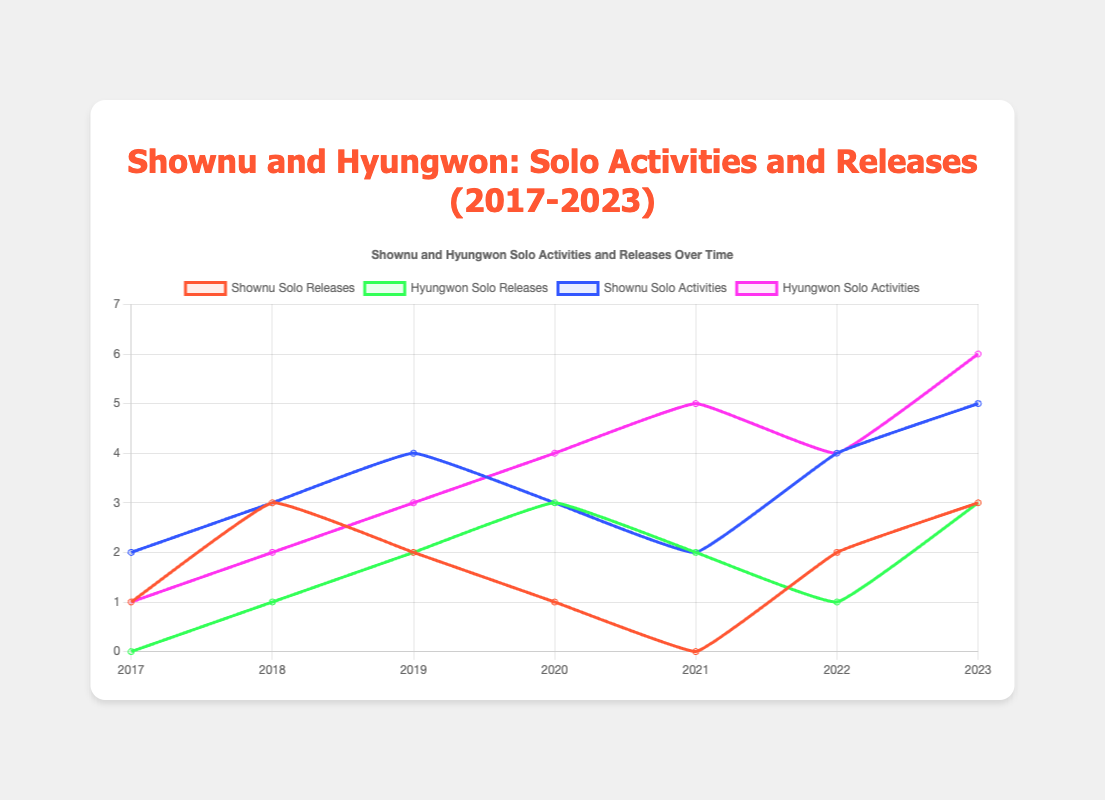How many more solo releases did Shownu have in 2018 compared to 2017? In 2018, Shownu had 3 solo releases, and in 2017, he had 1 solo release. The difference between these years is 3 - 1 = 2.
Answer: 2 In which year did Hyungwon match Shownu in solo releases, and how many releases did they have? Hyungwon matched Shownu in solo releases in 2019 and 2023, with both having 2 releases in 2019 and 3 releases in 2023.
Answer: 2019 and 2023, 2 releases (2019) and 3 releases (2023) In which year did Shownu and Hyungwon have the highest combined number of solo activities? To find the year with the highest combined solo activities, add Shownu's and Hyungwon's activities for each year and check the maximum. The sum for 2023 is 5 (Shownu) + 6 (Hyungwon) = 11, which is the highest.
Answer: 2023 How did Hyungwon's solo activities trend from 2017 to 2023? Hyungwon's solo activities increased from 1 in 2017 to 6 in 2023, showing an overall upward trend. Specifically, the counts were 1, 2, 3, 4, 5, 4, and 6 respectively for each year.
Answer: Increased Which years did Shownu and Hyungwon both have an equal number of solo activities, and what was that number? To find when their solo activities are equal, compare their yearly activities. In 2019 and 2022, both had 4 solo activities.
Answer: 2019 and 2022, 4 activities What is the trend in the number of solo releases for Shownu from 2021 to 2023? Shownu's solo releases increased from 0 in 2021 to 2 in 2022, and to 3 in 2023. The trend shows a steady increase over these years.
Answer: Increased In which year did Hyungwon have a higher number of solo releases compared to Shownu, and by how much? In 2020, Hyungwon had 3 solo releases while Shownu had 1. The difference is 3 - 1 = 2 releases.
Answer: 2020, 2 releases What is the average number of solo activities for Shownu over the given years? Sum Shownu's solo activities across all years and divide by the number of years. The activities sum to 2+3+4+3+2+4+5=23 over 7 years, giving an average of 23/7 ≈ 3.29.
Answer: 3.29 Which visual attributes on the chart indicate the number of solo activities for each artist? The lines and the filled area under the lines indicate solo activities. Shownu's activities are represented by a blue line, whereas Hyungwon's are shown by a purple line.
Answer: Blue (Shownu) and Purple (Hyungwon) What is the difference in the total number of solo activities between Shownu and Hyungwon from 2017 to 2023? Find the total number of solo activities for each over the years: Shownu (2+3+4+3+2+4+5=23) and Hyungwon (1+2+3+4+5+4+6=25). The difference is 25 - 23 = 2.
Answer: 2 